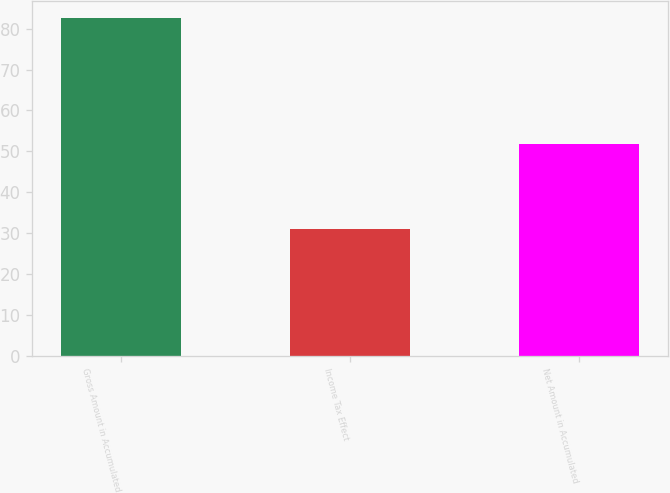Convert chart. <chart><loc_0><loc_0><loc_500><loc_500><bar_chart><fcel>Gross Amount in Accumulated<fcel>Income Tax Effect<fcel>Net Amount in Accumulated<nl><fcel>82.6<fcel>30.9<fcel>51.7<nl></chart> 